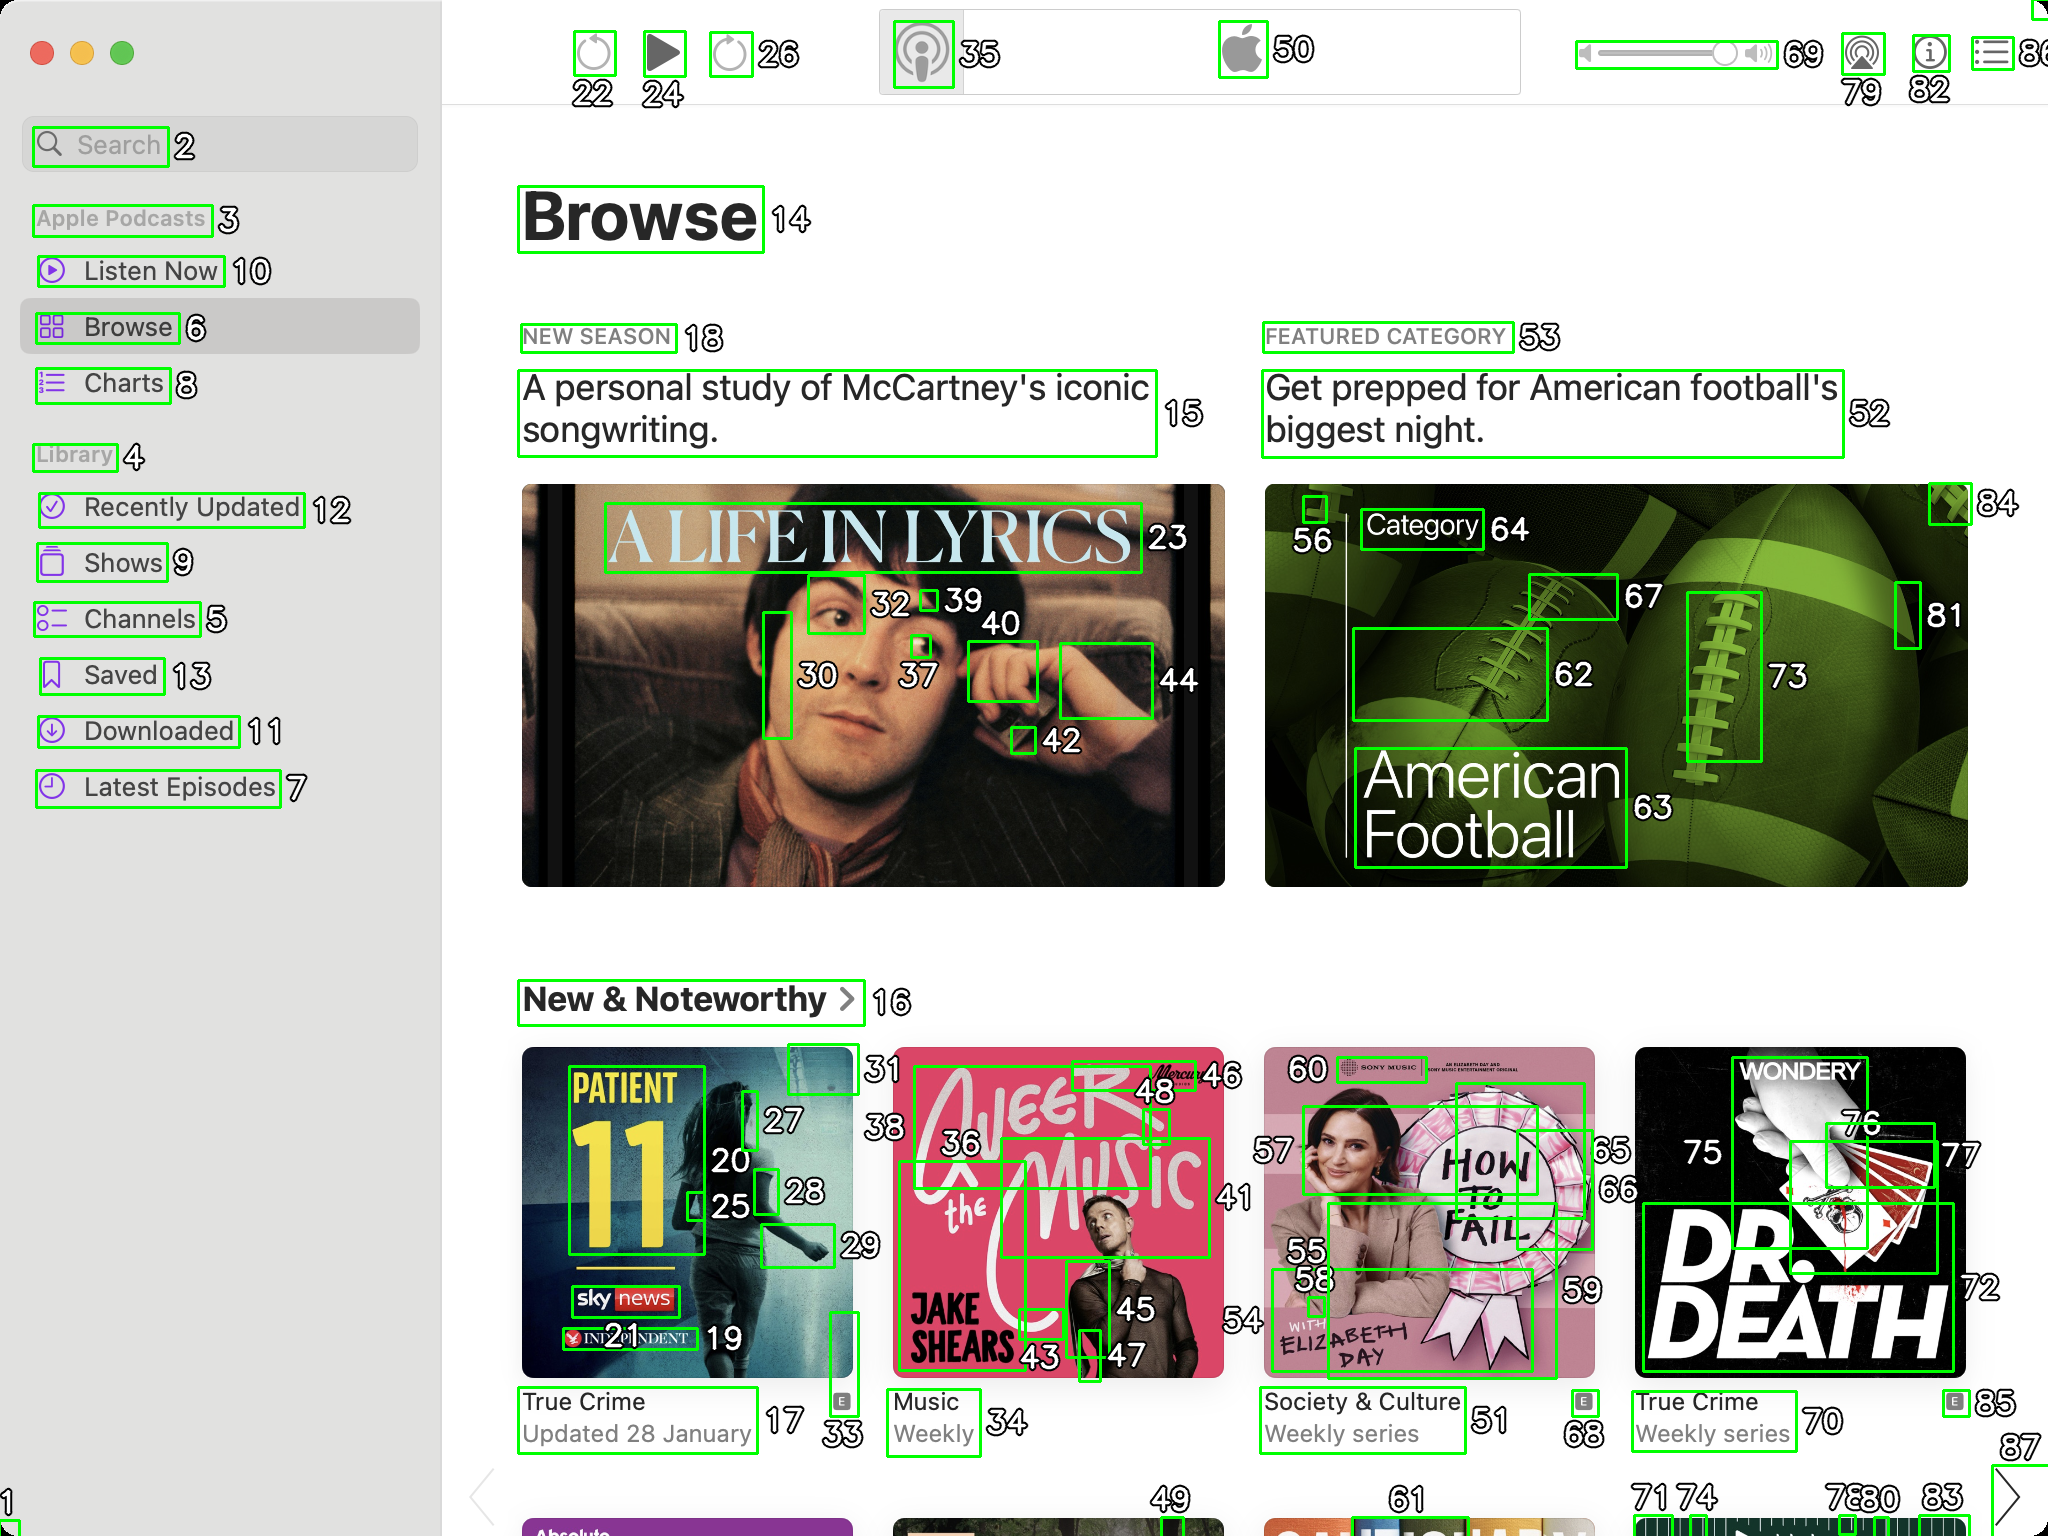You are an AI designed for image processing and segmentation analysis, particularly skilled in merging segmented regions of an image to improve accuracy and readability.

**Task Description:**
Your task is to address a user's concern with a UI screenshot of the Apple Podcasts application on MacOS. The screenshot contains multiple green boxes, each representing a UI element, with a unique white number outlined in black ranging from 1 to 88. Due to segmentation issues, some boxes that belong to the same UI element are divided unnaturally.

**Objective:**
Merge these segmented areas that correspond to a single UI element to create a coherent representation. The final output should be in JSON format, where each key-value pair represents the merged areas.
**Example JSON Output:**
If boxes with numbers 1, 2, and 3 should belong to the same UI element, the JSON output should be:

```json
{
    "UI Element 1": [1, 2, 3]
}
```
If to the box belongs only one segment — omit that box.

**Instructions:**

- **Identify Segmented Regions:** Analyze the screenshot to identify which green boxes belong to the same UI element.
- **Merge Regions:** Group the numbers of these boxes together to represent a single UI element.
- **Output Format:** Produce the output in JSON format, with each key representing a UI element and each value being a list of the numbers of the merged boxes.

**Primary Objective:**
Ensure the accuracy of the merged regions based on the user's supplied image information, maintaining the integrity and structure of the UI elements in the Apple Podcasts application on MacOS. Make sure that you merged only simple UI elements like images, text, inputs and so on, but not navbars, menus and sections. Based on the image provided, here is the JSON representation of the merged UI elements:

```json
{
    "UI Element 1": [1, 2],
    "UI Element 2": [4, 5],
    "UI Element 3": [6, 7, 8],
    "UI Element 4": [9, 10, 11, 12, 13],
    "UI Element 5": [14, 15],
    "UI Element 6": [18, 19],
    "UI Element 7": [20, 21],
    "UI Element 8": [23, 24, 25, 26],
    "UI Element 9": [27, 28, 29],
    "UI Element 10": [30, 31, 32, 33, 34, 35, 36, 37, 38, 39],
    "UI Element 11": [40, 41, 42, 43, 44],
    "UI Element 12": [45, 46, 47, 48, 49],
    "UI Element 13": [50, 51, 52, 53],
    "UI Element 14": [54, 55, 56, 57, 58, 59],
    "UI Element 15": [60, 61, 62, 63, 64, 65, 66, 67, 68],
    "UI Element 16": [69, 70, 71, 72, 73, 74],
    "UI Element 17": [75, 76, 77, 78, 79, 80, 81],
    "UI Element 18": [82, 83, 84, 85, 86, 87, 88]
}
```

In this JSON output, each key represents a UI element, and the value is an array of numbers that correspond to the segmented boxes making up that UI element. This should provide a coherent representation of the UI elements segmented in the screenshot. 